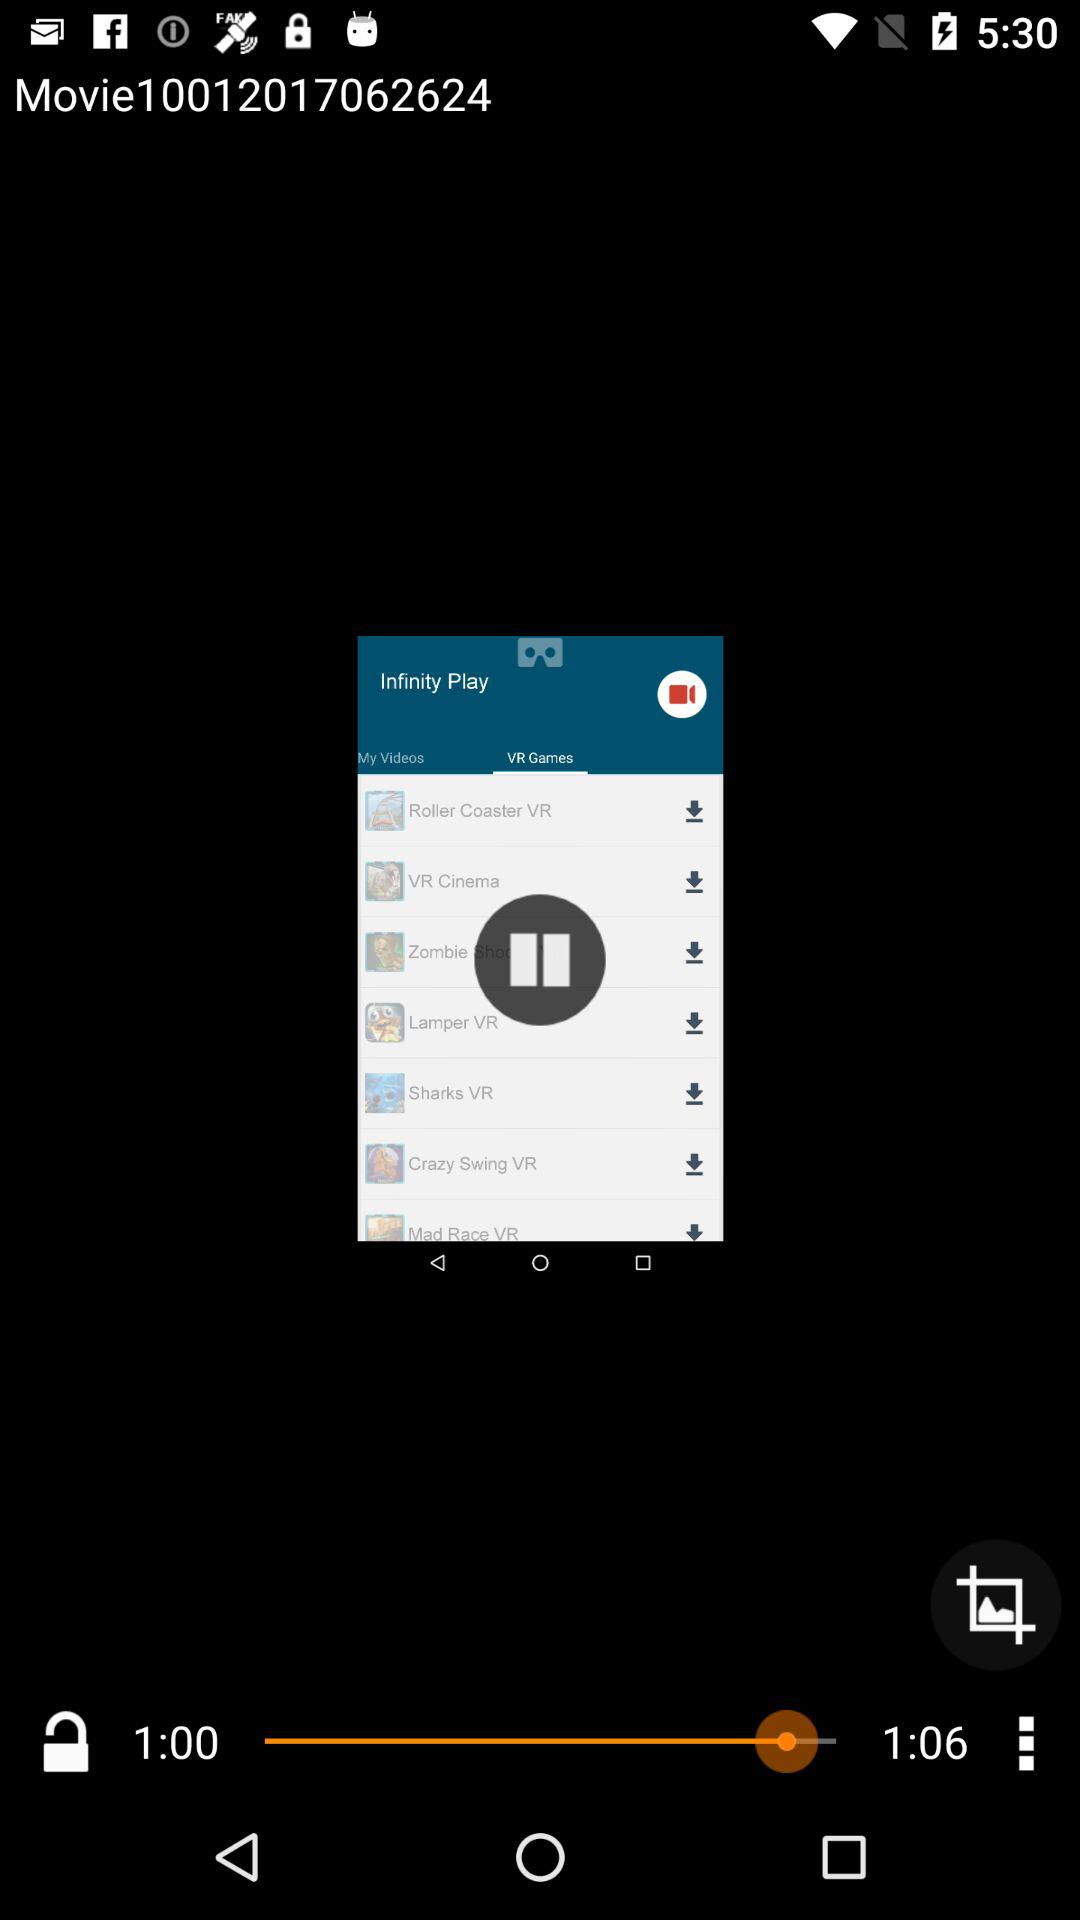What is the total movie time? The total movie time is 1:06. 